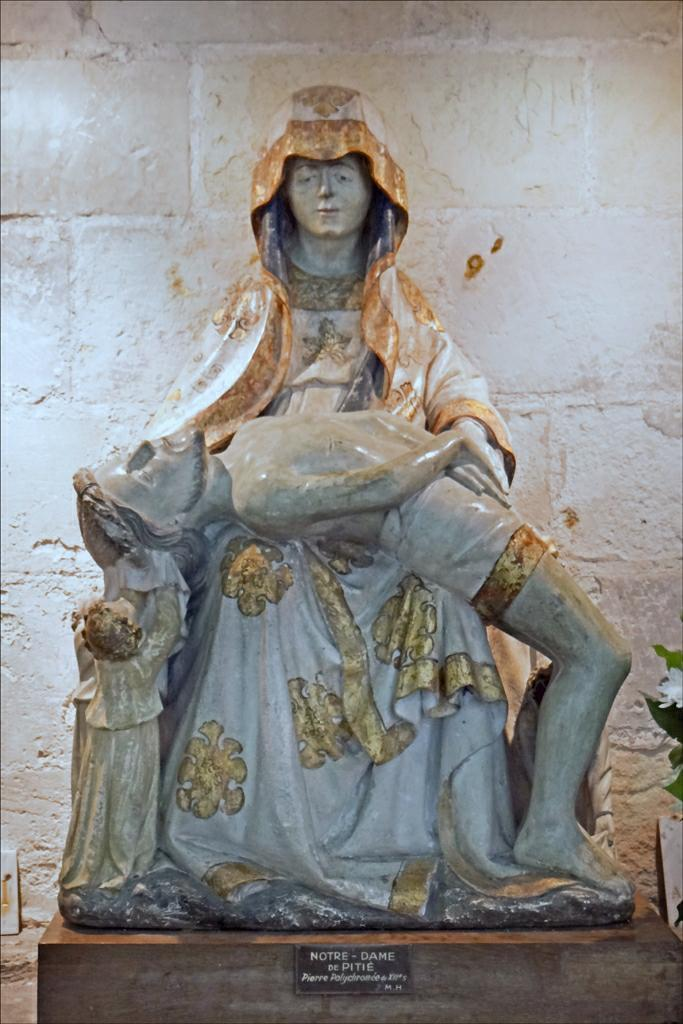What is the main subject of the image? There is a sculpture in the image. What can be seen in the background of the image? The background of the image is white. How many girls are swimming with the jellyfish in the image? There are no girls or jellyfish present in the image; it features a sculpture with a white background. What type of quartz can be seen in the image? There is no quartz present in the image. 